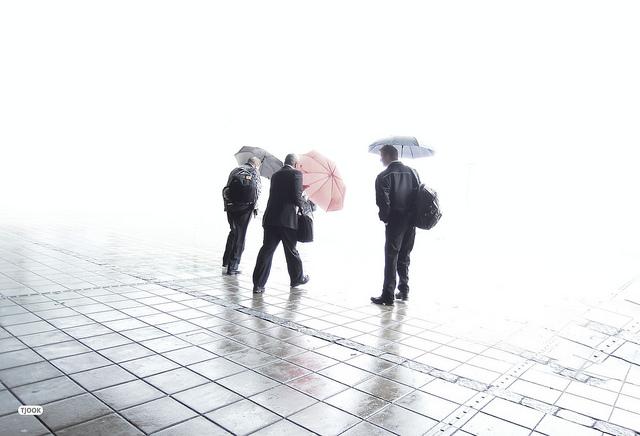How many umbrella the men are holding?
Give a very brief answer. 3. What is the main color of this picture?
Write a very short answer. White. What color is the umbrella in the middle?
Write a very short answer. Pink. What are they doing?
Write a very short answer. Walking. 